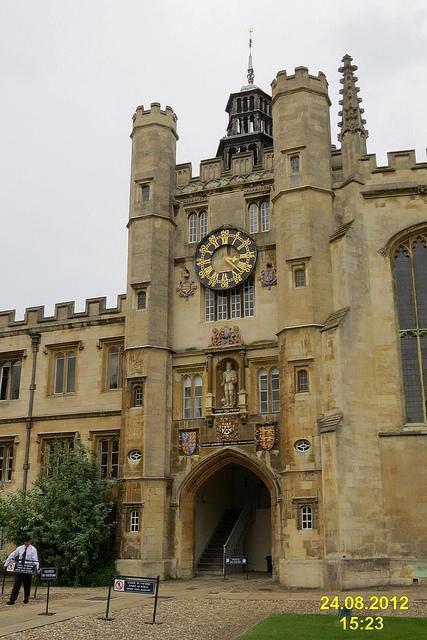What is the person on the left wearing? Please explain your reasoning. tie. The person in question is clearly visible and answer a is the most distinctly visible article of clothing they have on. 